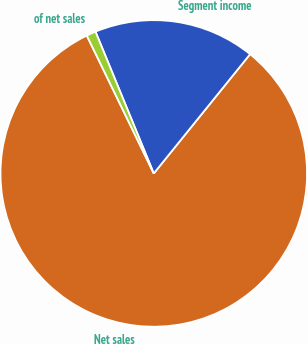<chart> <loc_0><loc_0><loc_500><loc_500><pie_chart><fcel>Net sales<fcel>Segment income<fcel>of net sales<nl><fcel>81.99%<fcel>17.02%<fcel>0.99%<nl></chart> 